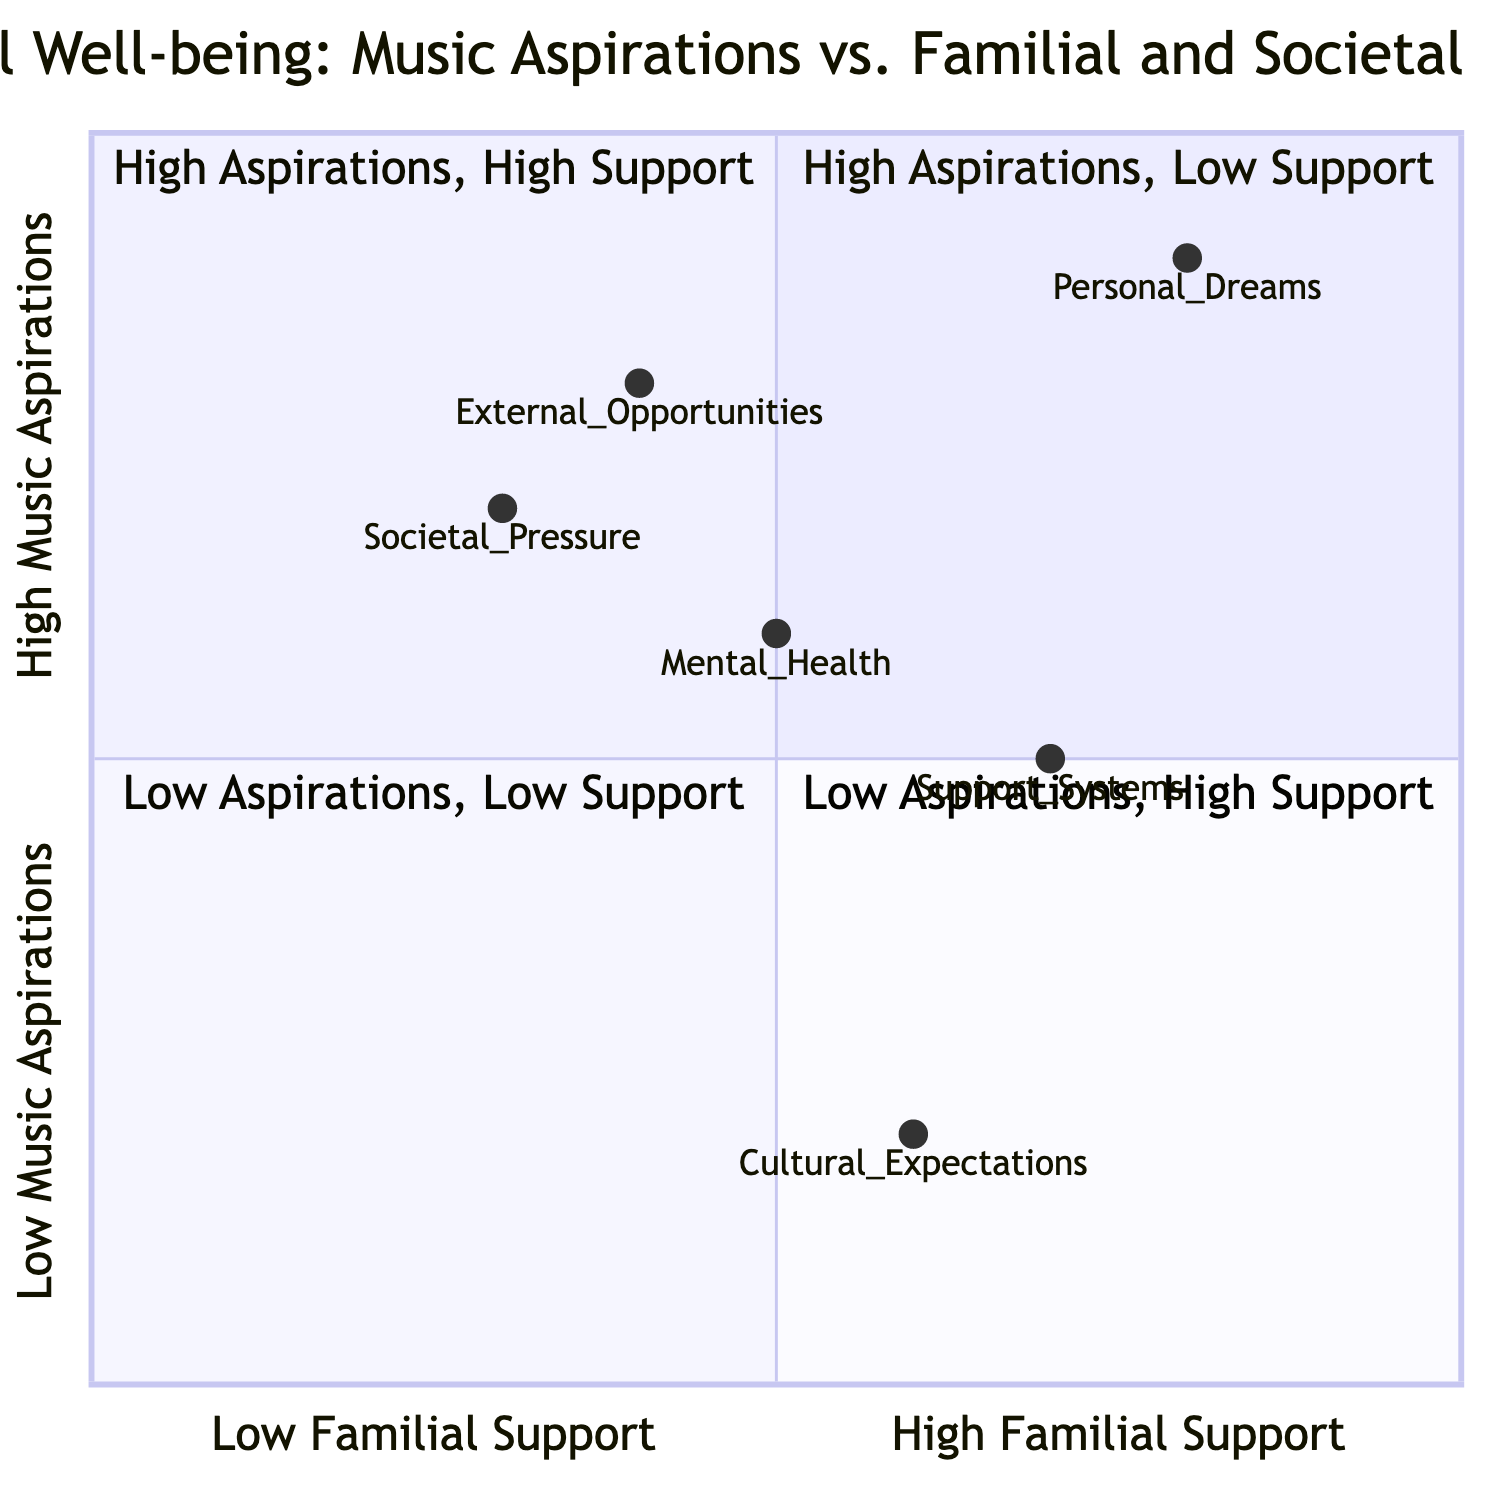What does Quadrant 1 represent? Quadrant 1 is labeled "High Music Aspirations, Low Familial Support," indicating it represents individuals who have strong ambitions in music but lack emotional and practical support from their families.
Answer: High Music Aspirations, Low Familial Support Which element is located in Quadrant 2? In Quadrant 2, which is "High Music Aspirations, High Familial Support," the element is "Personal Dreams." This indicates that those in this quadrant have both high ambitions and strong support from family.
Answer: Personal Dreams What is the societal pressure rating? The societal pressure rating is represented as [0.3, 0.7], placing it visually within the diagram and indicating the level of criticism faced in relation to music aspirations and familial pressures.
Answer: 0.3, 0.7 How many elements are in Quadrant 3? Quadrant 3 shows "Low Music Aspirations, Low Familial Support," but no specific elements are assigned to it in the data provided. Thus, the count is zero, signifying a lack of defined categories in this quadrant.
Answer: 0 Which quadrant has the lowest familial support? Quadrant 1 has the lowest familial support indicated by its positioning in the left portion of the chart, where familial support values are lower compared to the other quadrants, leading to fewer opportunities.
Answer: Quadrant 1 Which element is most affected by mental health concerns? "Mental Health" is an aspect that resonates significantly in all quadrants, especially in those with low support or aspirations, indicating that this element portrays a direct correlation to individuals' emotional well-being amidst pressure.
Answer: Mental Health What is the relationship between cultural expectations and societal pressure in the diagram? "Cultural Expectations" has a higher aspiration rating compared to "Societal Pressure," indicating that while cultural expectations may also impose pressures, the societal pressures are felt more acutely, impacting emotional states.
Answer: Societal Pressure has a higher impact 